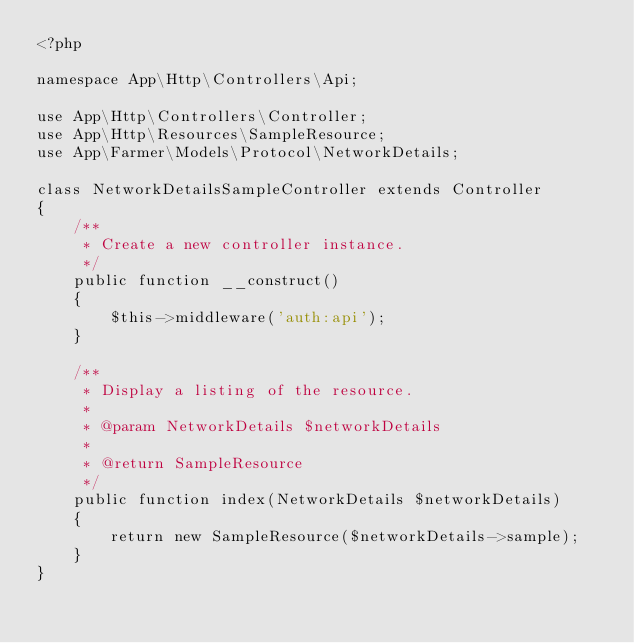Convert code to text. <code><loc_0><loc_0><loc_500><loc_500><_PHP_><?php

namespace App\Http\Controllers\Api;

use App\Http\Controllers\Controller;
use App\Http\Resources\SampleResource;
use App\Farmer\Models\Protocol\NetworkDetails;

class NetworkDetailsSampleController extends Controller
{
    /**
     * Create a new controller instance.
     */
    public function __construct()
    {
        $this->middleware('auth:api');
    }

    /**
     * Display a listing of the resource.
     *
     * @param NetworkDetails $networkDetails
     *
     * @return SampleResource
     */
    public function index(NetworkDetails $networkDetails)
    {
        return new SampleResource($networkDetails->sample);
    }
}
</code> 